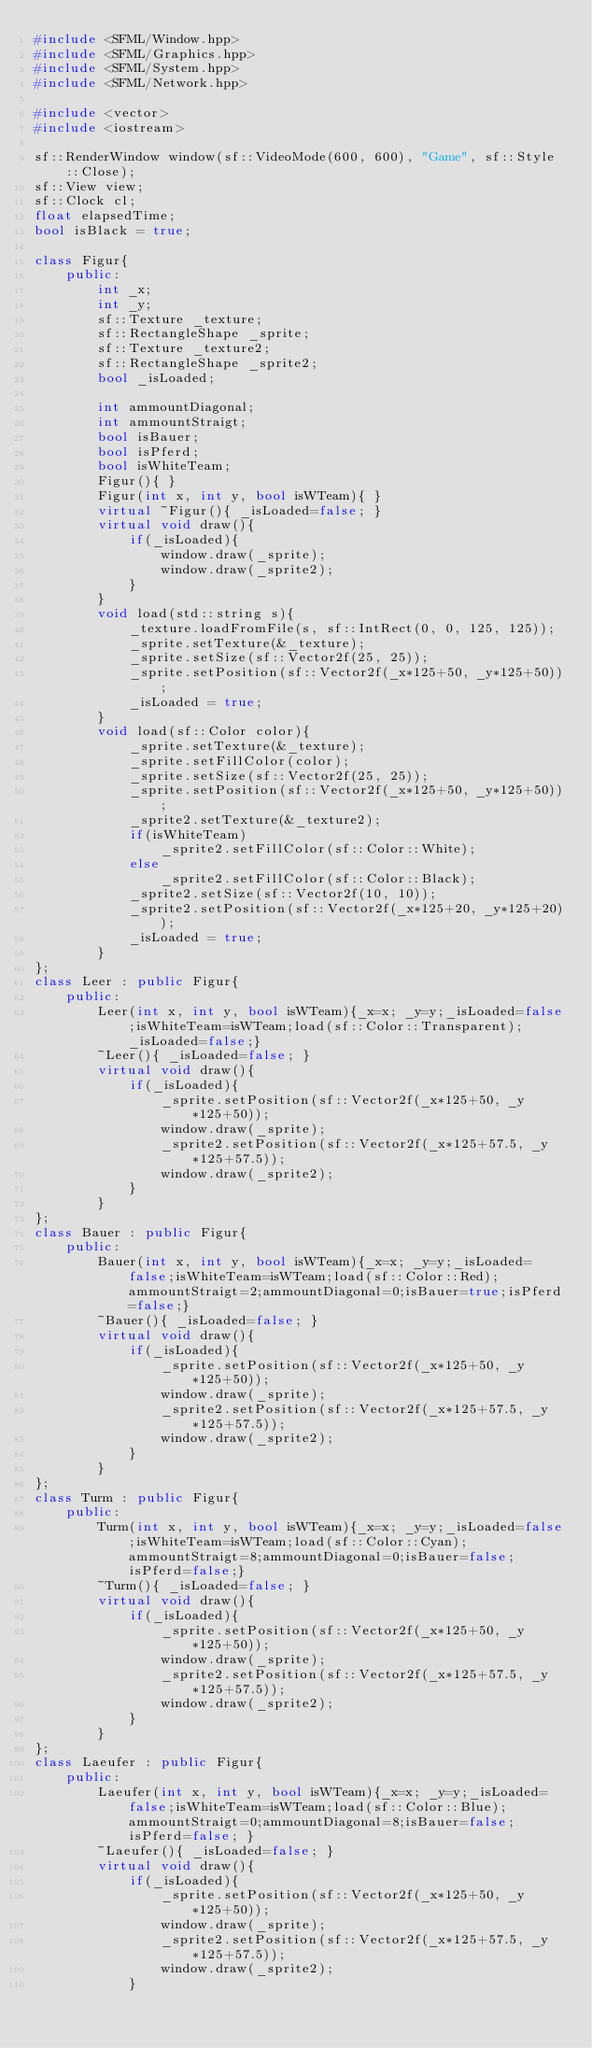Convert code to text. <code><loc_0><loc_0><loc_500><loc_500><_C++_>#include <SFML/Window.hpp>
#include <SFML/Graphics.hpp>
#include <SFML/System.hpp>
#include <SFML/Network.hpp>

#include <vector>
#include <iostream>

sf::RenderWindow window(sf::VideoMode(600, 600), "Game", sf::Style::Close);
sf::View view;
sf::Clock cl;
float elapsedTime;
bool isBlack = true;

class Figur{
	public:
		int _x;
		int _y;
		sf::Texture _texture;
		sf::RectangleShape _sprite;
		sf::Texture _texture2;
		sf::RectangleShape _sprite2;
		bool _isLoaded;

		int ammountDiagonal;
		int ammountStraigt;
		bool isBauer;
		bool isPferd;
		bool isWhiteTeam;
		Figur(){ }
		Figur(int x, int y, bool isWTeam){ }
		virtual ~Figur(){ _isLoaded=false; }
		virtual void draw(){
			if(_isLoaded){
				window.draw(_sprite);
				window.draw(_sprite2);
			}
		}
		void load(std::string s){
			_texture.loadFromFile(s, sf::IntRect(0, 0, 125, 125)); 
			_sprite.setTexture(&_texture);
			_sprite.setSize(sf::Vector2f(25, 25));
			_sprite.setPosition(sf::Vector2f(_x*125+50, _y*125+50));
			_isLoaded = true;
		}
		void load(sf::Color color){
			_sprite.setTexture(&_texture);
			_sprite.setFillColor(color);
			_sprite.setSize(sf::Vector2f(25, 25));
			_sprite.setPosition(sf::Vector2f(_x*125+50, _y*125+50));
			_sprite2.setTexture(&_texture2);
			if(isWhiteTeam)
				_sprite2.setFillColor(sf::Color::White);
			else
				_sprite2.setFillColor(sf::Color::Black);
			_sprite2.setSize(sf::Vector2f(10, 10));
			_sprite2.setPosition(sf::Vector2f(_x*125+20, _y*125+20));
			_isLoaded = true;
		}
};
class Leer : public Figur{
	public: 
		Leer(int x, int y, bool isWTeam){_x=x; _y=y;_isLoaded=false;isWhiteTeam=isWTeam;load(sf::Color::Transparent);_isLoaded=false;}
		~Leer(){ _isLoaded=false; }
		virtual void draw(){
			if(_isLoaded){
				_sprite.setPosition(sf::Vector2f(_x*125+50, _y*125+50));
				window.draw(_sprite);
				_sprite2.setPosition(sf::Vector2f(_x*125+57.5, _y*125+57.5));
				window.draw(_sprite2);
			}
		}
};
class Bauer : public Figur{
	public: 
		Bauer(int x, int y, bool isWTeam){_x=x; _y=y;_isLoaded=false;isWhiteTeam=isWTeam;load(sf::Color::Red);ammountStraigt=2;ammountDiagonal=0;isBauer=true;isPferd=false;}
		~Bauer(){ _isLoaded=false; }
		virtual void draw(){
			if(_isLoaded){
				_sprite.setPosition(sf::Vector2f(_x*125+50, _y*125+50));
				window.draw(_sprite);
				_sprite2.setPosition(sf::Vector2f(_x*125+57.5, _y*125+57.5));
				window.draw(_sprite2);
			}
		}
};
class Turm : public Figur{
	public: 
		Turm(int x, int y, bool isWTeam){_x=x; _y=y;_isLoaded=false;isWhiteTeam=isWTeam;load(sf::Color::Cyan);ammountStraigt=8;ammountDiagonal=0;isBauer=false;isPferd=false;}
		~Turm(){ _isLoaded=false; }
		virtual void draw(){
			if(_isLoaded){
				_sprite.setPosition(sf::Vector2f(_x*125+50, _y*125+50));
				window.draw(_sprite);
				_sprite2.setPosition(sf::Vector2f(_x*125+57.5, _y*125+57.5));
				window.draw(_sprite2);
			}
		}
};
class Laeufer : public Figur{
	public: 
		Laeufer(int x, int y, bool isWTeam){_x=x; _y=y;_isLoaded=false;isWhiteTeam=isWTeam;load(sf::Color::Blue);ammountStraigt=0;ammountDiagonal=8;isBauer=false;isPferd=false; }
		~Laeufer(){ _isLoaded=false; }
		virtual void draw(){
			if(_isLoaded){
				_sprite.setPosition(sf::Vector2f(_x*125+50, _y*125+50));
				window.draw(_sprite);
				_sprite2.setPosition(sf::Vector2f(_x*125+57.5, _y*125+57.5));
				window.draw(_sprite2);
			}</code> 